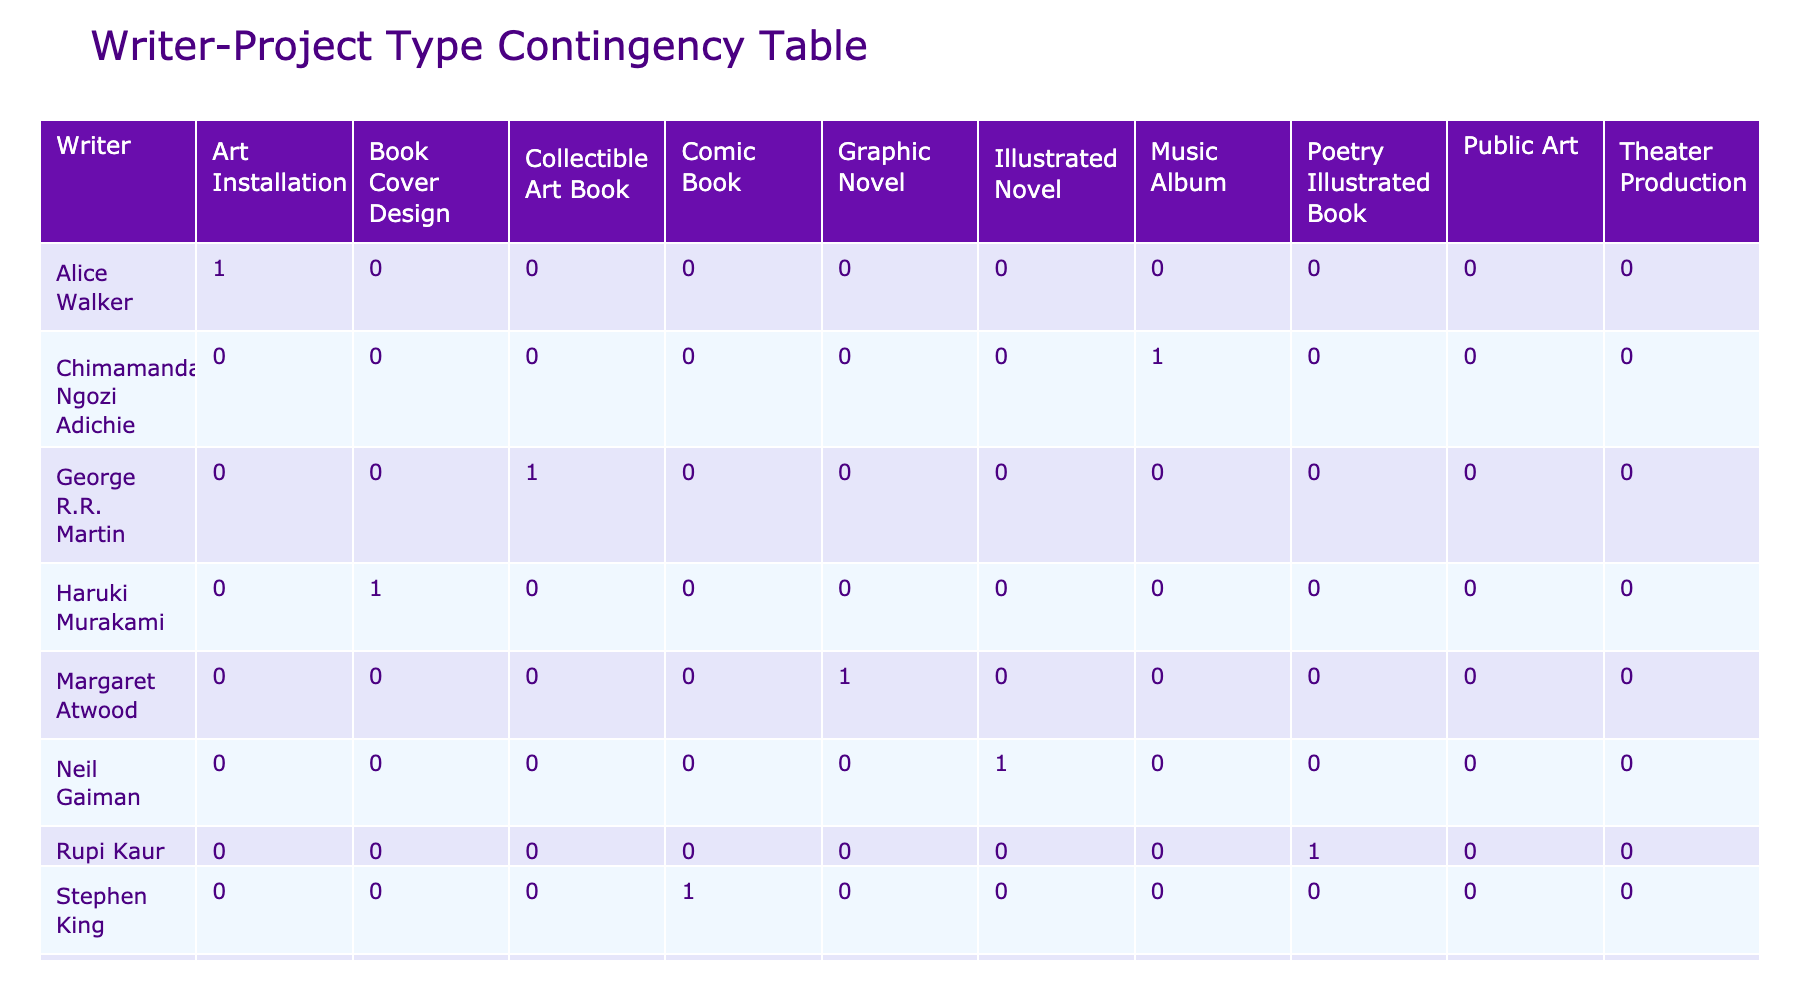What is the total number of writers involved in graphic novel projects? There is one writer involved in graphic novel projects, specifically Margaret Atwood, who collaborated with Kara Walker.
Answer: 1 Which project type has the highest number of collaborations? There are three project types represented in the table: Graphic Novel, Illustrated Novel, Art Installation, Book Cover Design, Theater Production, Comic Book, Public Art, Music Album, Collectible Art Book, and Poetry Illustrated Book. Each appears once, so no single type has a higher number of collaborations.
Answer: None Is there a project type that only features one writer? Yes, each project type in the table is associated with only one writer.
Answer: Yes How many total project types are represented in the table? There are ten unique project types listed: Graphic Novel, Illustrated Novel, Art Installation, Book Cover Design, Theater Production, Comic Book, Public Art, Music Album, Collectible Art Book, and Poetry Illustrated Book. Counting these gives a total of 10 project types.
Answer: 10 How many project types are associated with fantasy genre? The genres listed are Fantasy, Dystopian, Social Justice, Literary Fiction, Historical, Horror, Urban Commentary, Afrofuturism, and Contemporary Poetry. Among these, two project types are labeled as Fantasy: Neil Gaiman's Illustrated Novel and George R.R. Martin's Collectible Art Book. Thus, there are two project types that fall under the fantasy genre.
Answer: 2 Which writer has collaborated on a music album, and what is the project type? The writer is Chimamanda Ngozi Adichie, who collaborated with Femi Kuti on a Music Album. This information can be extracted directly from the table.
Answer: Chimamanda Ngozi Adichie How many more theater production projects are there compared to comic book projects? The table shows that there is one theater production project (Toni Morrison with Romare Bearden) and one comic book project (Stephen King with Bernie Wrightson). Therefore, the difference is zero as they are equal.
Answer: 0 Are there any projects that belong to the horror genre? Yes, the project associated with the horror genre is the Comic Book created by Stephen King in collaboration with Bernie Wrightson. This can be verified by looking at the genre column in the table.
Answer: Yes What is the rarity of collaborations in the contemporary poetry genre? There is one project noted in the contemporary poetry genre, which is Rupi Kaur's Poetry Illustrated Book, indicating it is quite rare compared to other genres that have multiple representations. Counting gives us one instance of contemporary poetry.
Answer: Rare 